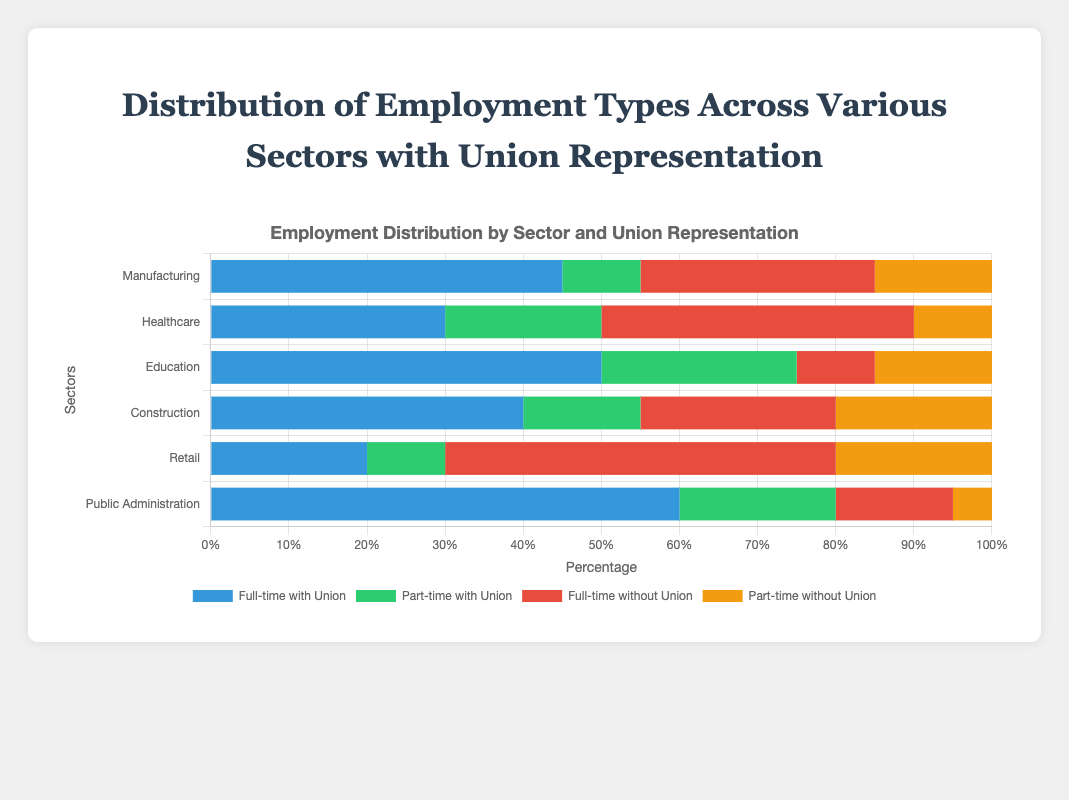What sector has the highest proportion of full-time employees with union representation? By looking at the bars labeled "Full-time with Union", the longest bar corresponds to the sector. The "Public Administration" sector has the highest proportion with a value of 60.
Answer: Public Administration In the Healthcare sector, is the number of part-time employees with union representation greater than the number of part-time employees without union representation? We compare the lengths of the two bars for the Healthcare sector under "Part-time with Union" (20) and "Part-time without Union" (10). Since 20 is greater than 10, the number of part-time employees with union representation is greater.
Answer: Yes Which sector has the smallest proportion of full-time employees without union representation? Looking at the "Full-time without Union" bars, the smallest bar corresponds to the Education sector with a value of 10.
Answer: Education In the Manufacturing sector, what is the total number of employees with union representation (both full-time and part-time)? Add the "Full-time with Union" and "Part-time with Union" values for Manufacturing: 45 (full-time) + 10 (part-time) = 55.
Answer: 55 How does the proportion of full-time employees with union representation in Retail compare to the proportion of full-time employees without union representation in the same sector? Compare the lengths of the "Full-time with Union" (20) and "Full-time without Union" (50) bars for the Retail sector. The "Full-time without Union" bar is significantly longer.
Answer: The proportion without union representation is higher Which sector has a higher total number of employees without union representation, Construction or Healthcare? Calculate the total for each sector by summing the "Full-time without Union" and "Part-time without Union" values. Construction: 25 (full-time) + 20 (part-time) = 45. Healthcare: 40 (full-time) + 10 (part-time) = 50. Healthcare has a higher total.
Answer: Healthcare In the Education sector, what is the difference between the number of full-time employees with union representation and full-time employees without union representation? Subtract the "Full-time without Union" value from the "Full-time with Union" value: 50 (with union) - 10 (without union) = 40.
Answer: 40 Are there any sectors where the number of part-time employees with union representation is equal to the number of part-time employees without union representation? Compare the bars for "Part-time with Union" and "Part-time without Union" for each sector. There are no sectors where these values are equal.
Answer: No 